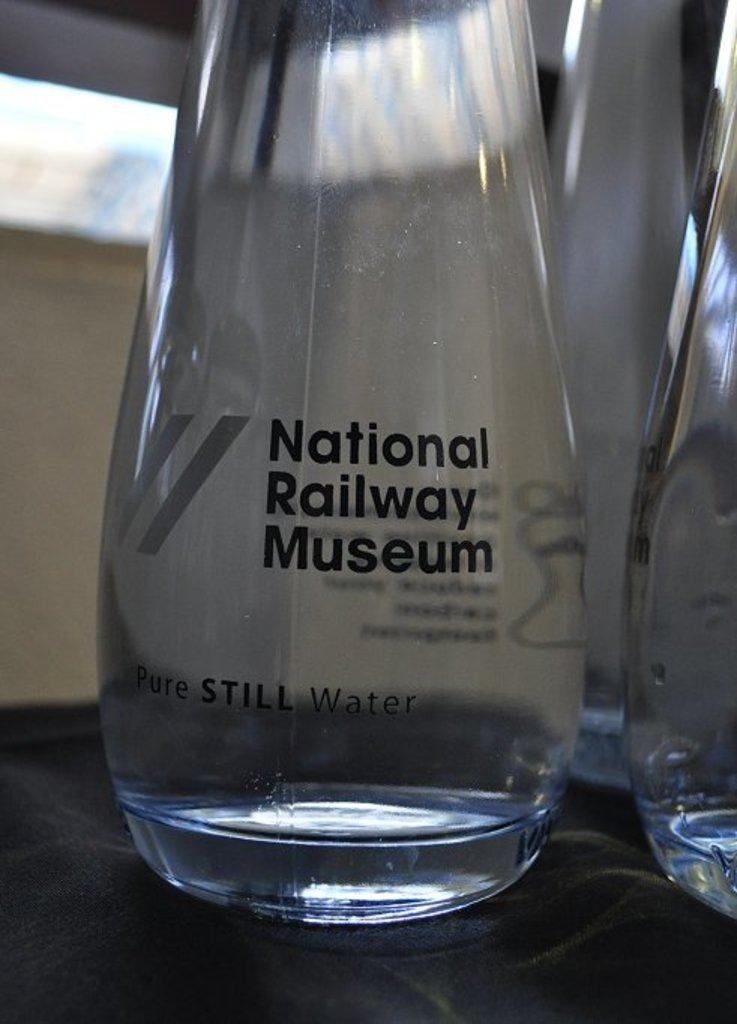What type of containers are visible in the image? There are bottles of glass in the image. What type of cord is attached to the bottles in the image? There is no cord attached to the bottles in the image; they are simply bottles of glass. 